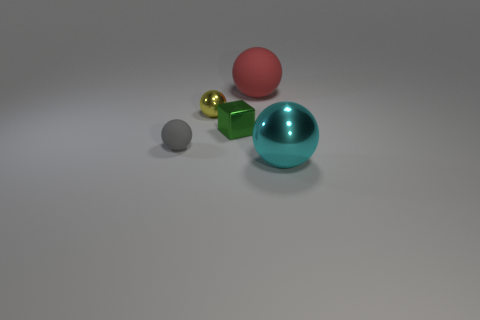Are there more purple matte spheres than large objects?
Keep it short and to the point. No. There is a rubber object behind the shiny sphere behind the matte ball to the left of the block; what color is it?
Provide a short and direct response. Red. How many rubber balls are on the right side of the thing left of the tiny yellow metallic ball?
Provide a succinct answer. 1. Is there a big gray object?
Your response must be concise. No. Is the number of big blue rubber blocks less than the number of things?
Offer a terse response. Yes. There is a large thing on the left side of the metallic sphere to the right of the small yellow metallic ball; what is its shape?
Offer a terse response. Sphere. There is a small gray rubber ball; are there any red balls behind it?
Provide a succinct answer. Yes. There is a metal sphere that is the same size as the red rubber thing; what color is it?
Offer a terse response. Cyan. What number of other small balls are the same material as the gray sphere?
Provide a short and direct response. 0. What number of other objects are the same size as the cyan metallic ball?
Your answer should be very brief. 1. 